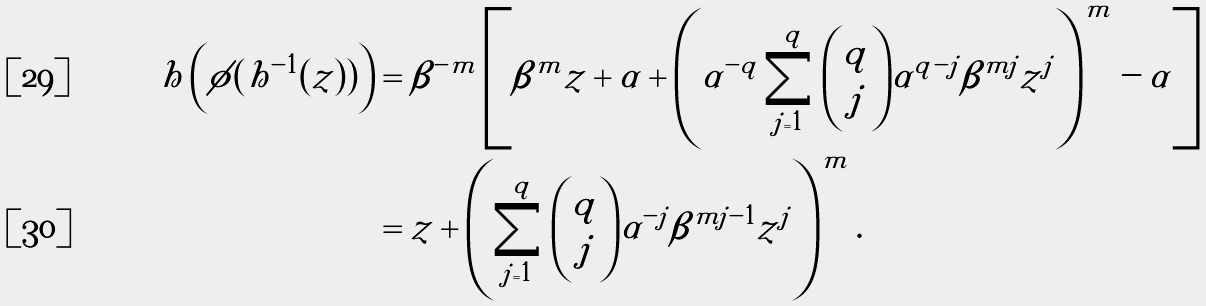<formula> <loc_0><loc_0><loc_500><loc_500>h \left ( \phi ( h ^ { - 1 } ( z ) ) \right ) & = \beta ^ { - m } \left [ \beta ^ { m } z + \alpha + \left ( \alpha ^ { - q } \sum _ { j = 1 } ^ { q } \binom { q } { j } \alpha ^ { q - j } \beta ^ { m j } z ^ { j } \right ) ^ { m } - \alpha \right ] \\ & = z + \left ( \sum _ { j = 1 } ^ { q } \binom { q } { j } \alpha ^ { - j } \beta ^ { m j - 1 } z ^ { j } \right ) ^ { m } .</formula> 